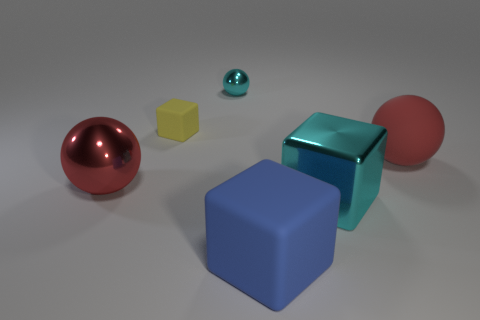Subtract all yellow cylinders. How many red spheres are left? 2 Subtract all red balls. How many balls are left? 1 Add 1 big red balls. How many objects exist? 7 Subtract all purple blocks. Subtract all brown spheres. How many blocks are left? 3 Subtract all small green rubber cubes. Subtract all large cyan cubes. How many objects are left? 5 Add 3 tiny metal things. How many tiny metal things are left? 4 Add 5 large rubber balls. How many large rubber balls exist? 6 Subtract 0 purple spheres. How many objects are left? 6 